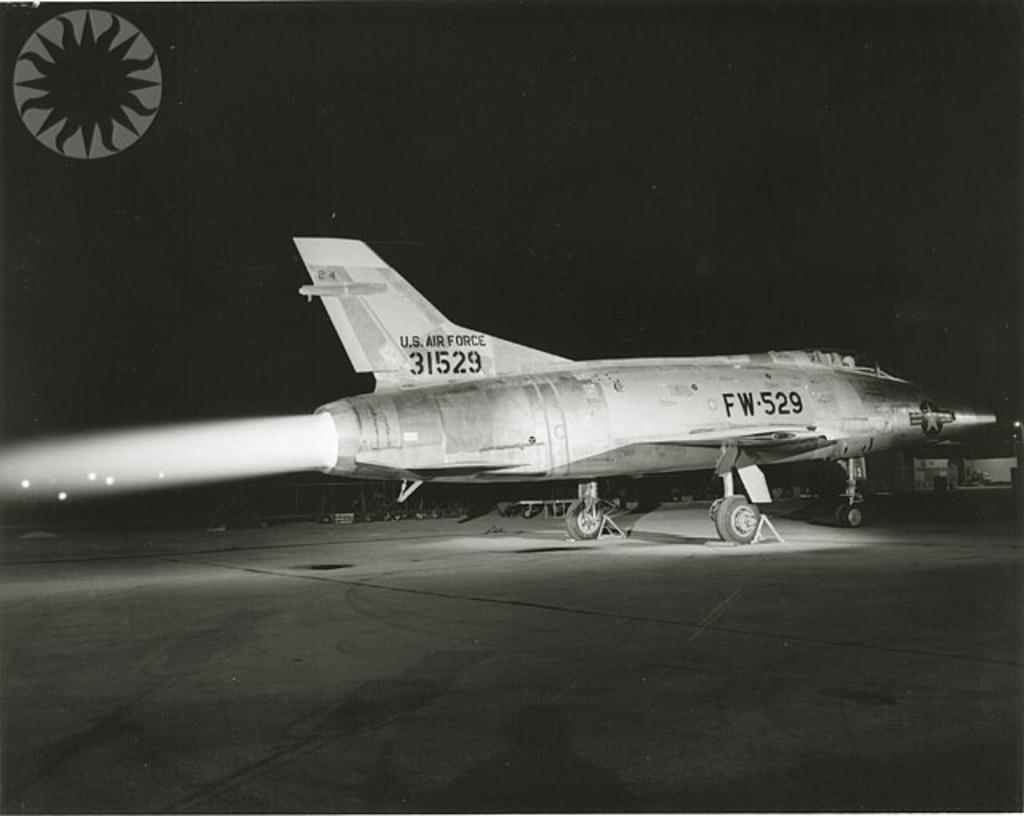<image>
Render a clear and concise summary of the photo. a Us air force jet is started up and blowing heat from the back 